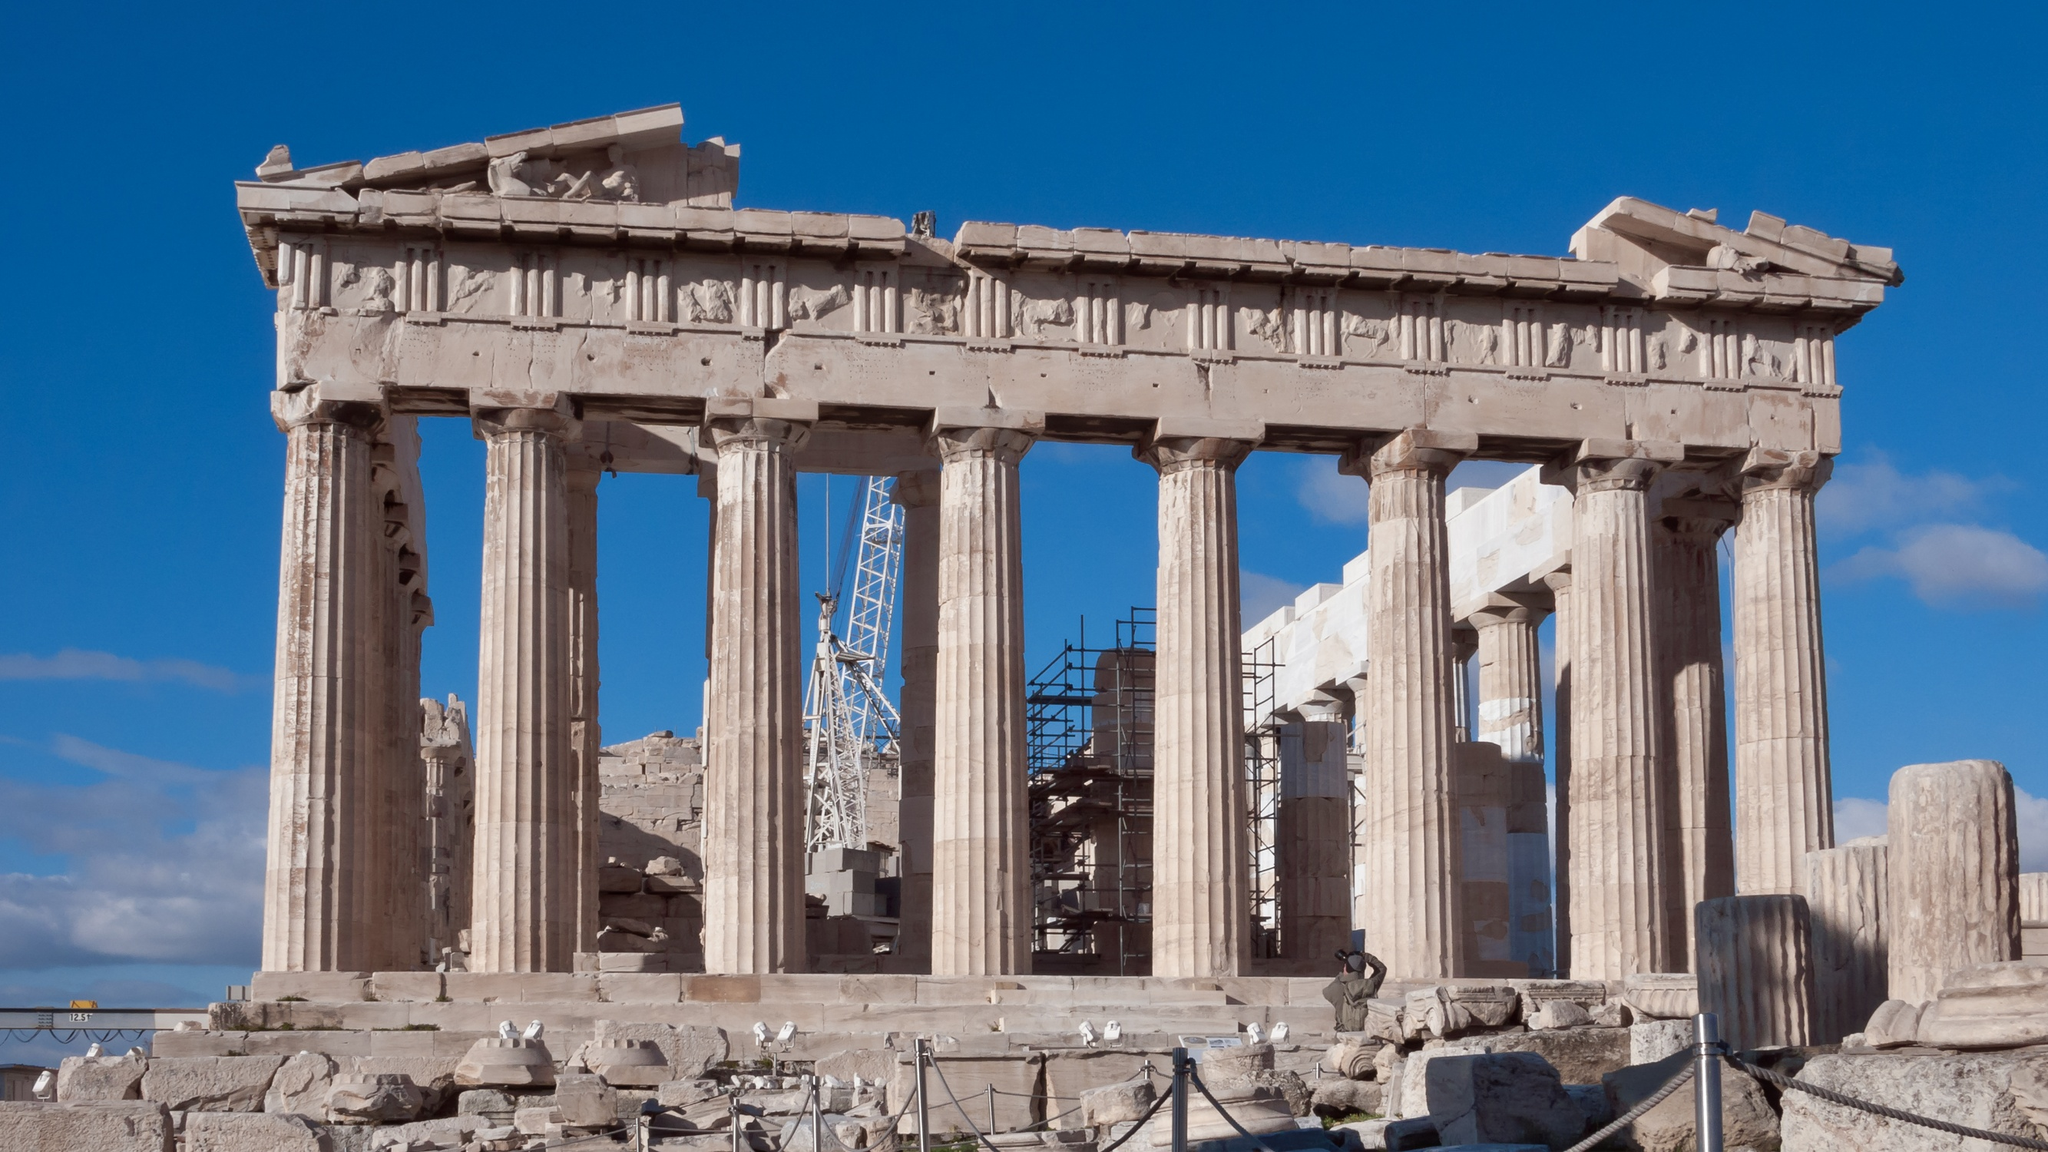Can you tell me more about the historical events associated with the Parthenon? Certainly! The Parthenon was completed in 438 BC during the reign of Pericles, and it was dedicated to Athena Parthenos, the goddess whom the people of Athens considered their patron. Its artistic and architectural grandeur symbolizes the zenith of Athenian power and cultural achievement in the Golden Age of Athens. Over the centuries, it has served multiple roles: from a temple, to a treasury, a Christian church, a mosque, and even a powder magazine – which led to severe damage in 1687 during a Venetian attack. 